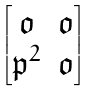<formula> <loc_0><loc_0><loc_500><loc_500>\begin{bmatrix} \mathfrak { o } & \mathfrak { o } \\ \mathfrak { p } ^ { 2 } & \mathfrak { o } \end{bmatrix}</formula> 